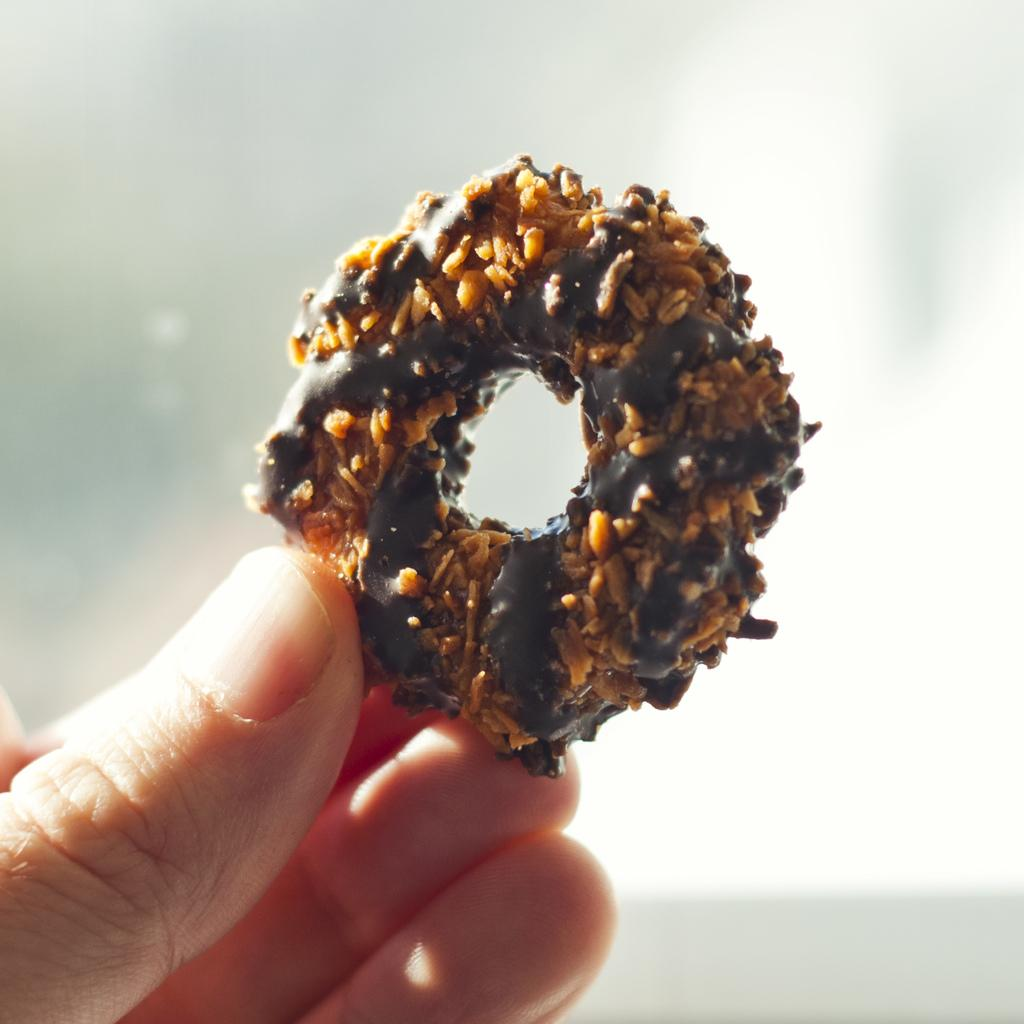What can be seen in the person's hand in the image? The person's hand is holding a donut in the image. What is the color of the background in the image? The background of the image is white. What type of potato is being used to poison the person in the image? There is no potato or poison present in the image; it only shows a person's hand holding a donut. 